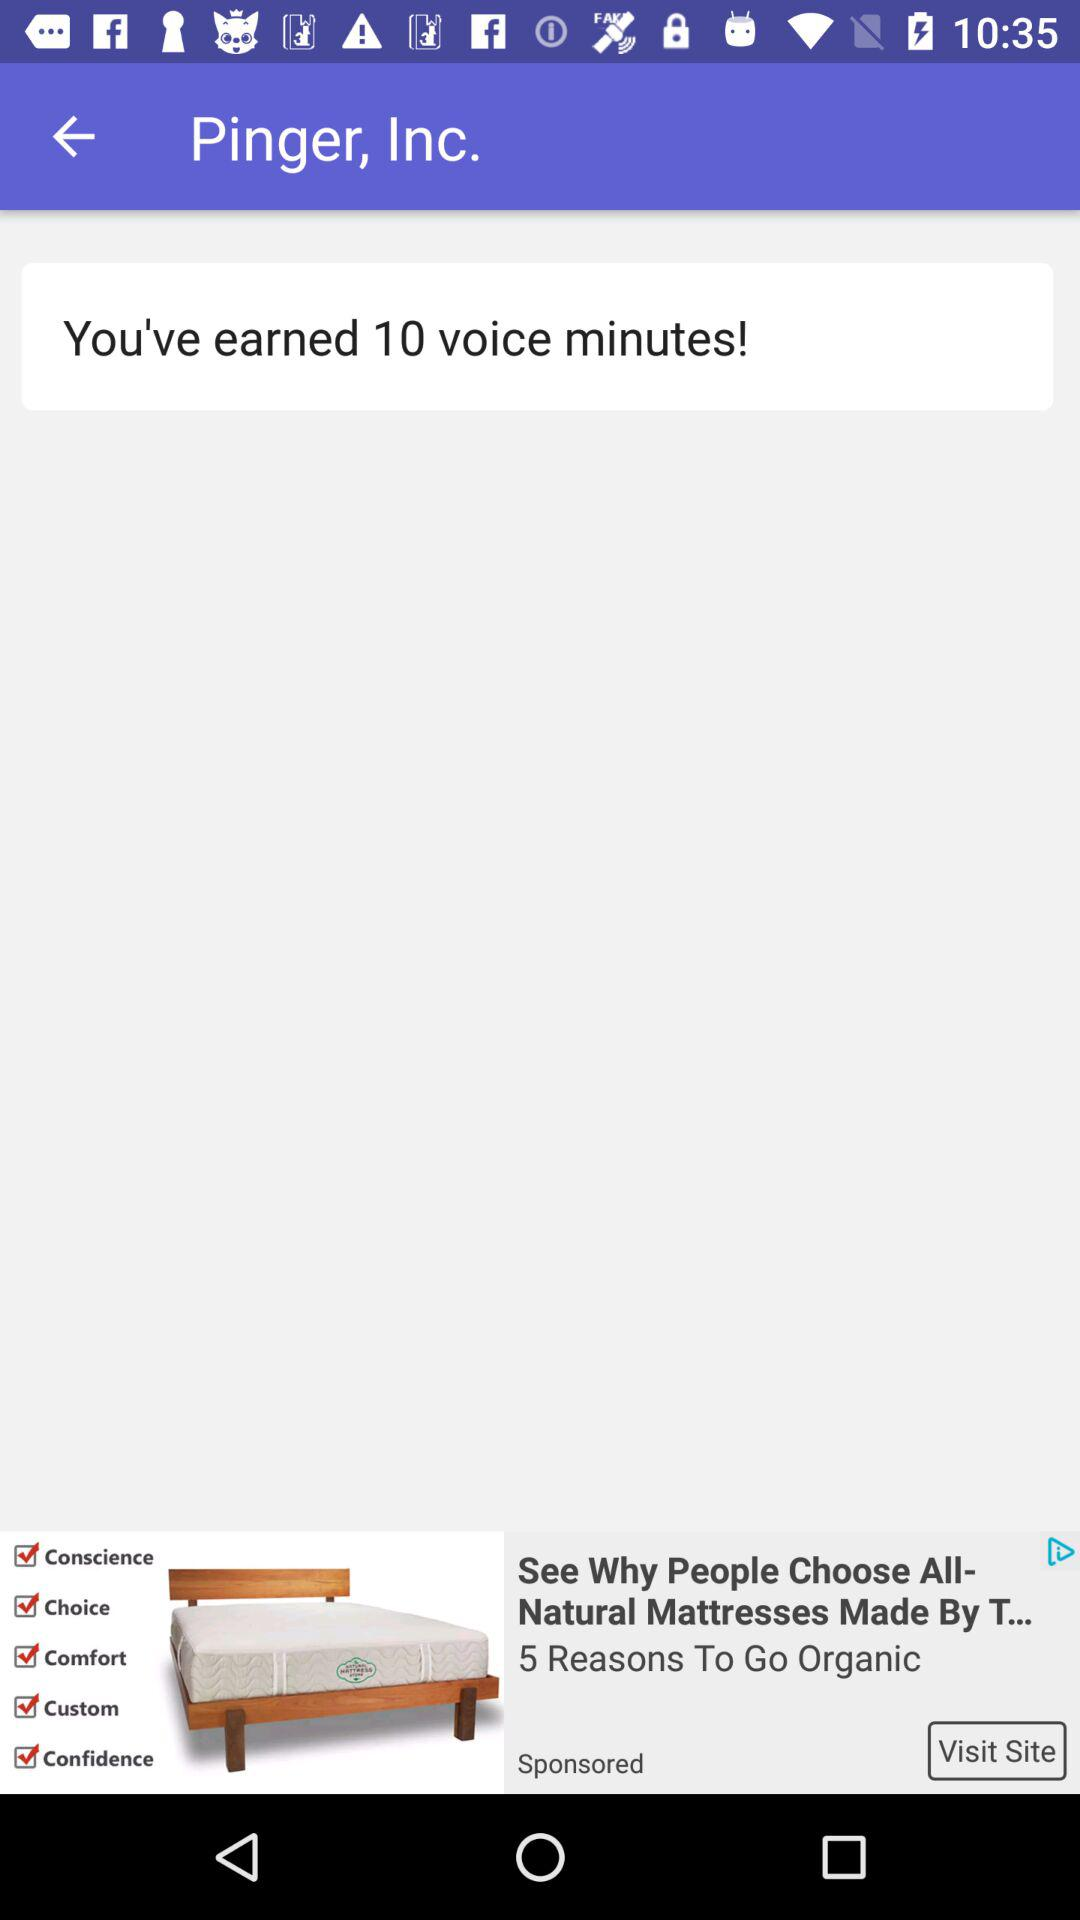What is the app name? The app name is "Pinger, Inc.". 